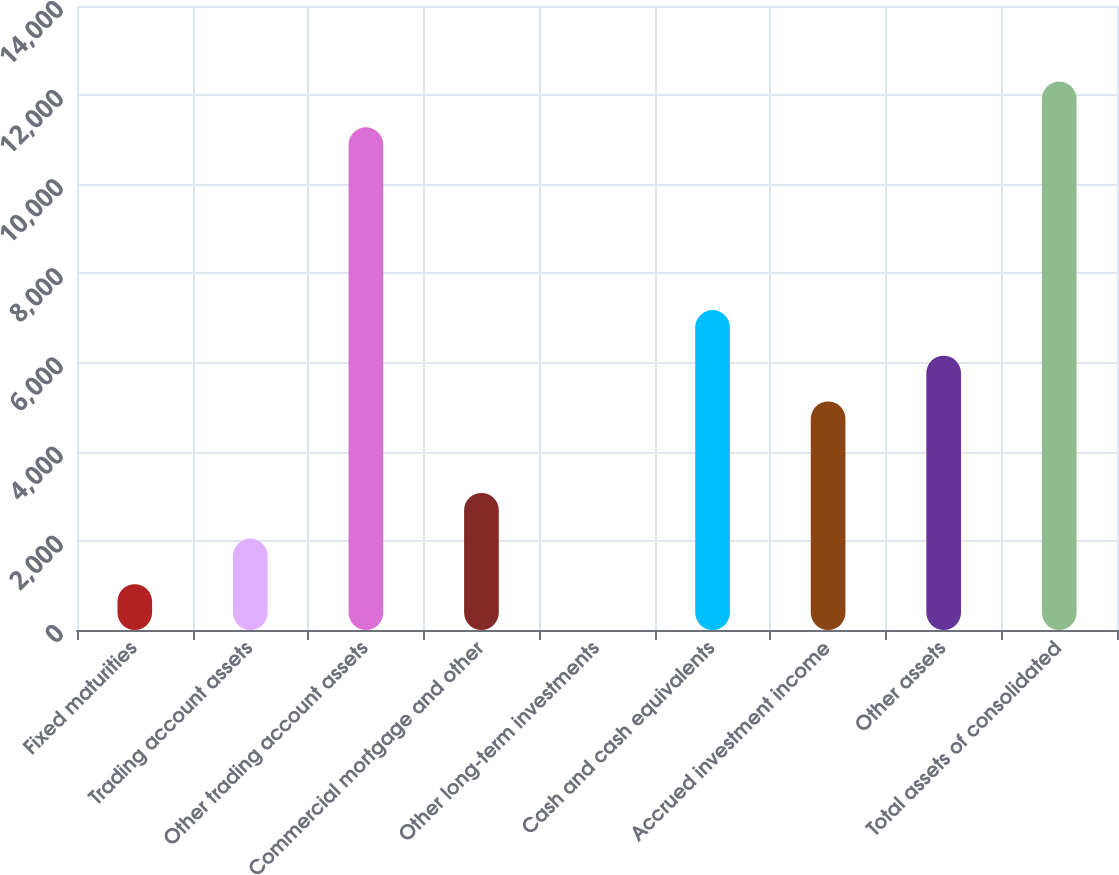<chart> <loc_0><loc_0><loc_500><loc_500><bar_chart><fcel>Fixed maturities<fcel>Trading account assets<fcel>Other trading account assets<fcel>Commercial mortgage and other<fcel>Other long-term investments<fcel>Cash and cash equivalents<fcel>Accrued investment income<fcel>Other assets<fcel>Total assets of consolidated<nl><fcel>1026.04<fcel>2051.26<fcel>11278.2<fcel>3076.48<fcel>0.82<fcel>7177.36<fcel>5126.92<fcel>6152.14<fcel>12303.5<nl></chart> 